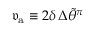<formula> <loc_0><loc_0><loc_500><loc_500>\mathfrak { v } _ { a } \equiv 2 \delta \, \Delta \widetilde { \theta } ^ { \pi }</formula> 